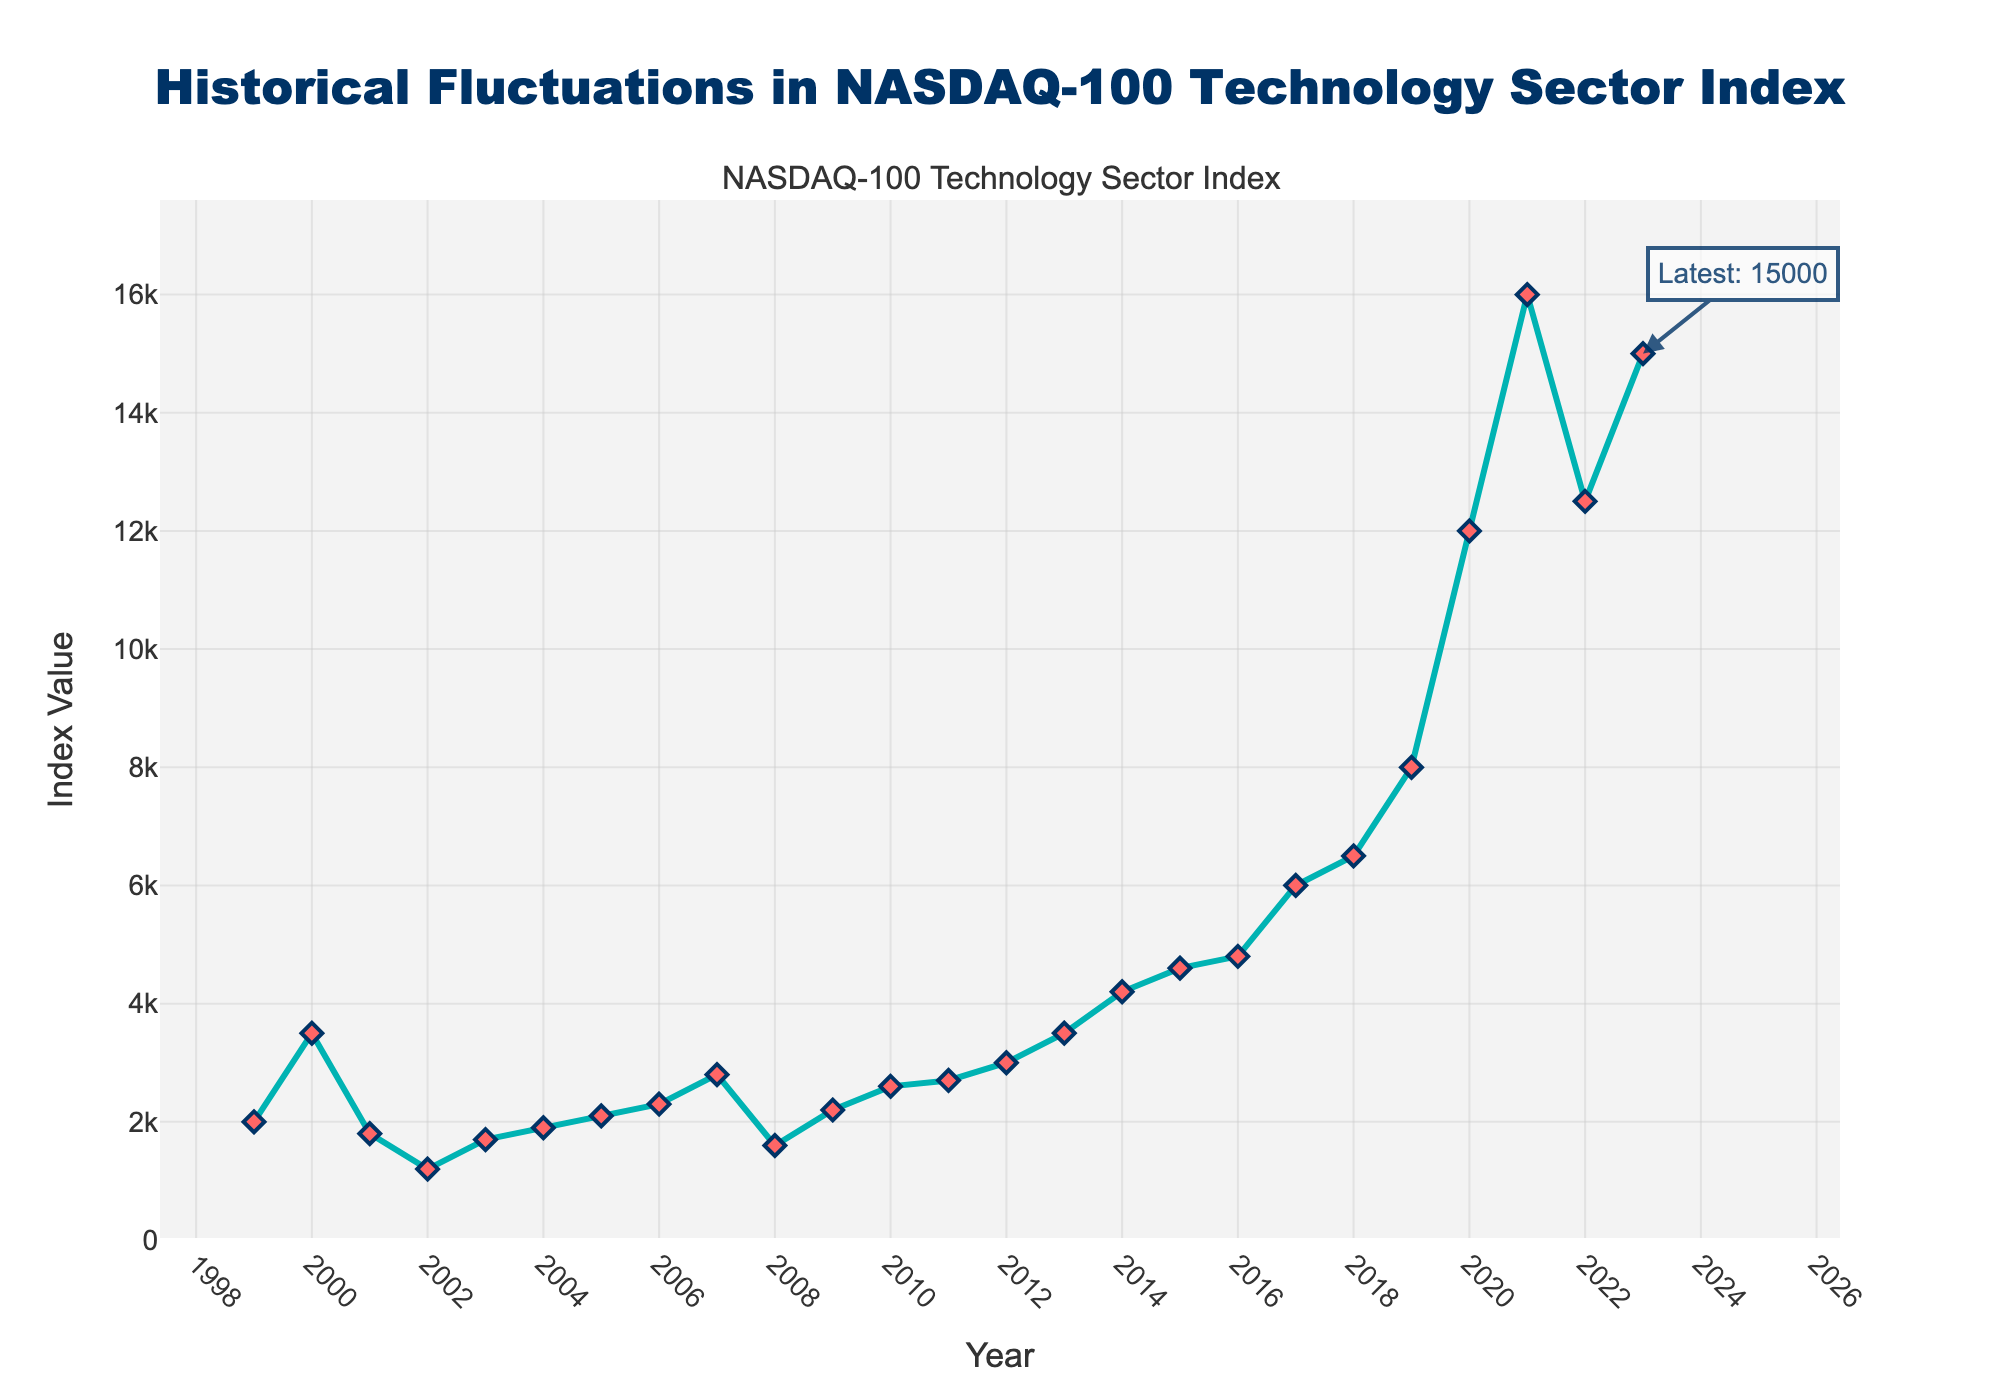What year did the NASDAQ-100 Technology Sector Index peak? To determine the year when the NASDAQ-100 Technology Sector Index peaked, locate the highest point on the line chart. The highest value on the chart is at 16,000, and this occurs in the year 2021.
Answer: 2021 What was the difference in index values between the dot-com boom peak in 2000 and the trough in 2002? Identify the index values for 2000 and 2002 from the chart. The value for 2000 is 3,500 and for 2002 is 1,200. Subtract the lower value from the higher: 3,500 - 1,200 = 2,300.
Answer: 2,300 Which year experienced the largest one-year increase in the index value? Look at the slopes of the line segments between consecutive years. The largest jump is from 2019 (8,000) to 2020 (12,000). Calculate the difference: 12,000 - 8,000 = 4,000.
Answer: 2020 How many times did the index value drop between two consecutive years? Count the number of times the line segment slopes downward between two data points. The drops occurred in the years: 2000-2001, 2001-2002, 2007-2008, and 2021-2022. This sums up to 4 times.
Answer: 4 What is the average index value from 2017 to 2021? Identify the index values for the years 2017 to 2021: 6,000 (2017), 6,500 (2018), 8,000 (2019), 12,000 (2020), and 16,000 (2021). Sum these values: 6,000 + 6,500 + 8,000 + 12,000 + 16,000 = 48,500. Divide by the number of years (5): 48,500 / 5 = 9,700.
Answer: 9,700 Did the index value more than triple from any year to another year within the given data range? To determine this, compare the index values of each year to each of the subsequent years to find if any subsequent value is more than three times (i.e., >300% increase). Comparing 2008 (1,600) to 2023 (15,000) yields 9.375 times, which is indeed more than triple.
Answer: Yes What was the index value in 2023, and how does it compare to the value in 2019? Read the values directly from the chart: 2023 has an index value of 15,000 and 2019 has an index value of 8,000. Compare these values by subtraction: 15,000 - 8,000 = 7,000.
Answer: The index in 2023 was 7,000 points higher Which year had the sharp decline post the dot-com boom, and by how much did the index value decrease? Identify the year after the dot-com bubble burst in 2000 where the decline is sharpest. The most significant drop is from 2000 (3,500) to 2001 (1,800). The decrease is 3,500 - 1,800 = 1,700.
Answer: 2001, by 1,700 What is the latest index value annotated on the chart? The latest index value is explicitly annotated on the figure. The annotation shows "Latest: 15,000" at the year 2023.
Answer: 15,000 